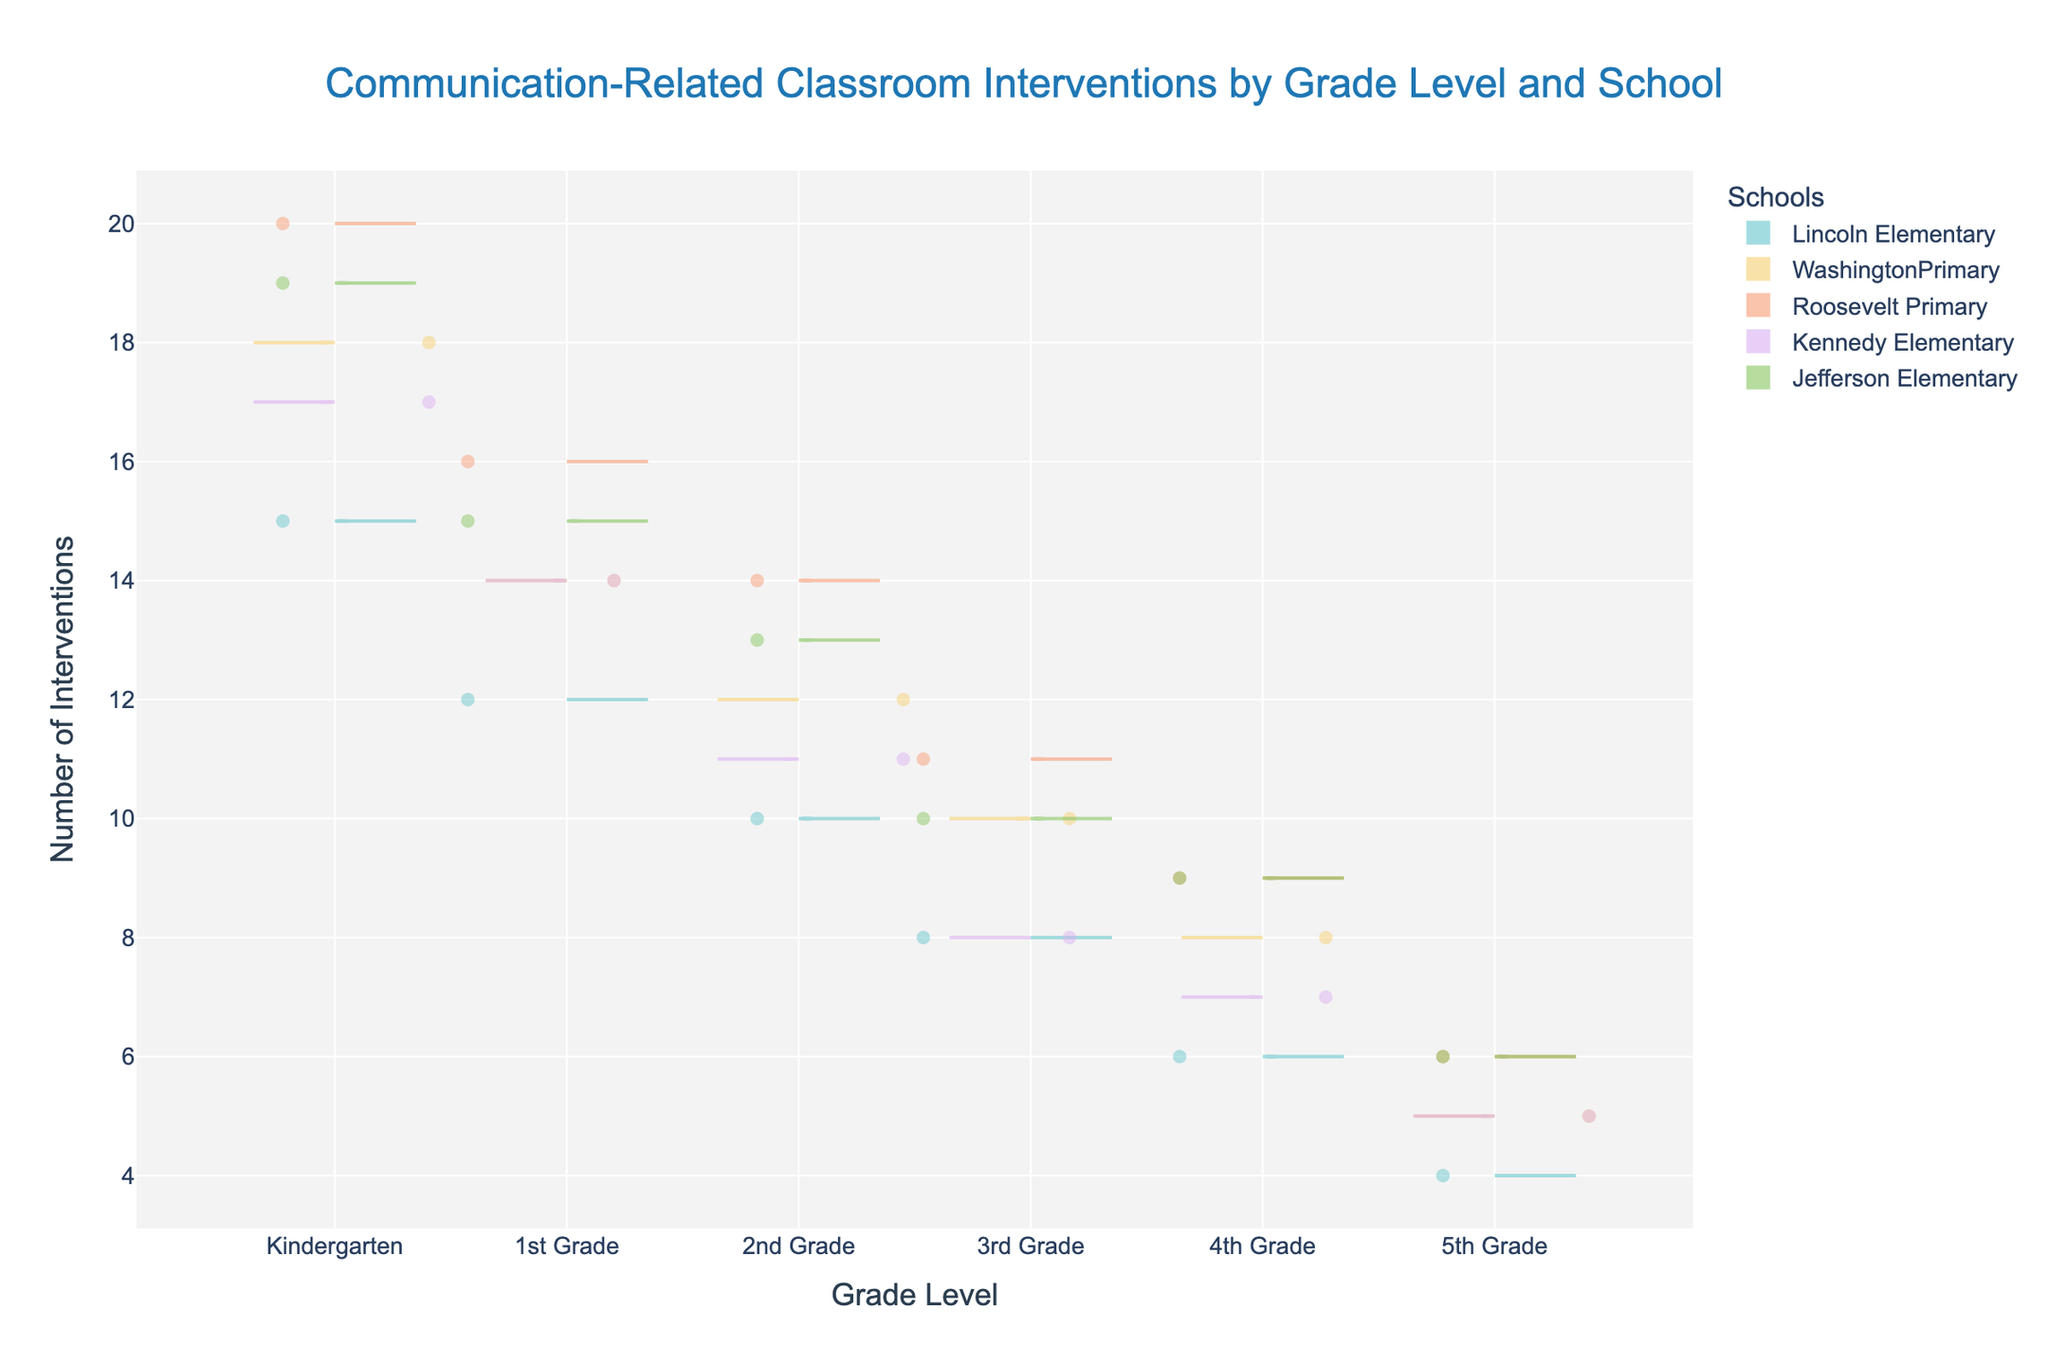What schools are included in the figure? The figure includes data from all the schools listed in the dataset. Looking at the legend, we can see the names of all the schools participating in the study.
Answer: Lincoln Elementary, Washington Primary, Roosevelt Primary, Kennedy Elementary, Jefferson Elementary What grade level has the highest number of interventions at Jefferson Elementary? By examining the data points and distribution for Jefferson Elementary, we can see that the highest number of interventions occurs in Kindergarten, with noticeably more data points concentrated at higher values compared to other grade levels.
Answer: Kindergarten Which school has the least number of interventions for 3rd Grade? Looking at the 3rd Grade data points and their distribution across all schools, Lincoln Elementary displays the fewest interventions compared to others.
Answer: Lincoln Elementary For Kennedy Elementary, how does the number of interventions in Kindergarten compare to 4th Grade? From the plot, we can observe that Kennedy Elementary has a higher number of interventions in Kindergarten compared to 4th Grade based on the spread and concentration of data points.
Answer: More in Kindergarten What is the trend in the number of interventions as grade levels increase for Lincoln Elementary? By following the distribution of interventions from Kindergarten through to 5th Grade, we see a decreasing trend, indicating fewer interventions as grade levels advance.
Answer: Decreasing Which school displays the widest variation in the number of interventions for 1st Grade? Reviewing the spread of data points for 1st Grade across all schools, Roosevelt Primary has the widest variation in values, as reflected by the spread and range of its violin plot.
Answer: Roosevelt Primary Between Roosevelt Primary and Washington Primary, which school has a higher median number of interventions in Kindergarten? By comparing the central points in the distributions (spine of the violins) for Kindergarten, Roosevelt Primary has a higher median number of interventions than Washington Primary.
Answer: Roosevelt Primary How does the number of interventions for 5th Grade at Lincoln Elementary compare to the same grade at Jefferson Elementary? Comparing the distributions, Jefferson Elementary has more data points at higher values for 5th Grade than Lincoln Elementary.
Answer: Higher at Jefferson Elementary 